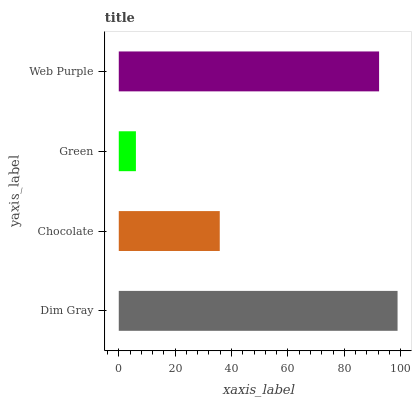Is Green the minimum?
Answer yes or no. Yes. Is Dim Gray the maximum?
Answer yes or no. Yes. Is Chocolate the minimum?
Answer yes or no. No. Is Chocolate the maximum?
Answer yes or no. No. Is Dim Gray greater than Chocolate?
Answer yes or no. Yes. Is Chocolate less than Dim Gray?
Answer yes or no. Yes. Is Chocolate greater than Dim Gray?
Answer yes or no. No. Is Dim Gray less than Chocolate?
Answer yes or no. No. Is Web Purple the high median?
Answer yes or no. Yes. Is Chocolate the low median?
Answer yes or no. Yes. Is Green the high median?
Answer yes or no. No. Is Green the low median?
Answer yes or no. No. 